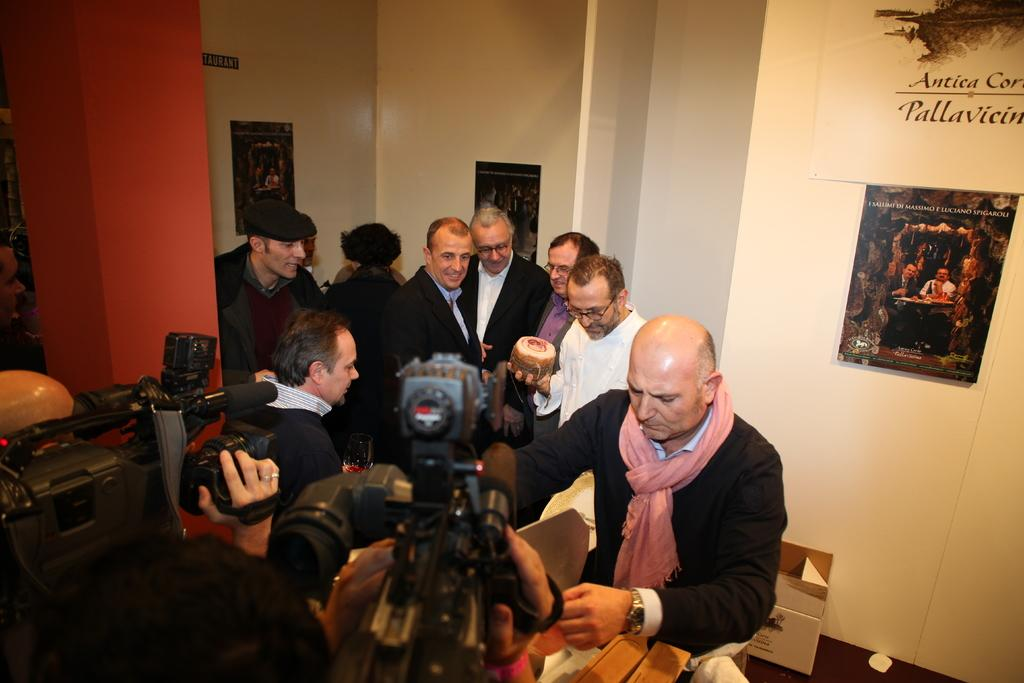How many people are in the image? There is a group of people in the image. What is one person doing specifically? One person is doing something specific, but we cannot determine the exact action without more information. How many people are holding cameras? Two people are holding cameras. What can be seen on the wall in the background? There are frames attached to the wall in the background. What type of hat is the person wearing in the image? There is no hat visible in the image. What time of day is it in the image? The time of day cannot be determined from the image alone. 